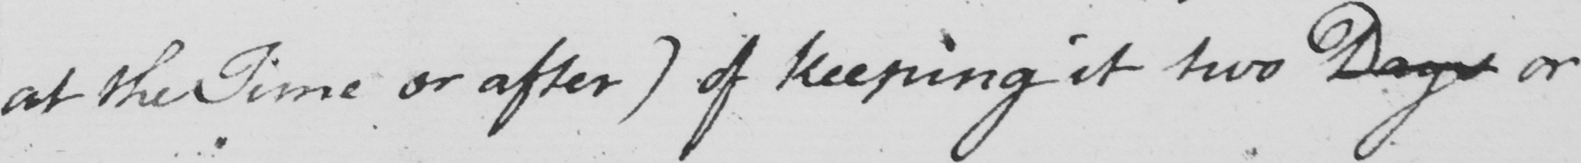Can you read and transcribe this handwriting? at the Time or after )  of keeping it two Days or 